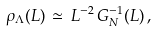<formula> <loc_0><loc_0><loc_500><loc_500>\rho _ { \Lambda } ( L ) \, \simeq \, L ^ { - 2 } \, G _ { N } ^ { - 1 } ( L ) \, ,</formula> 